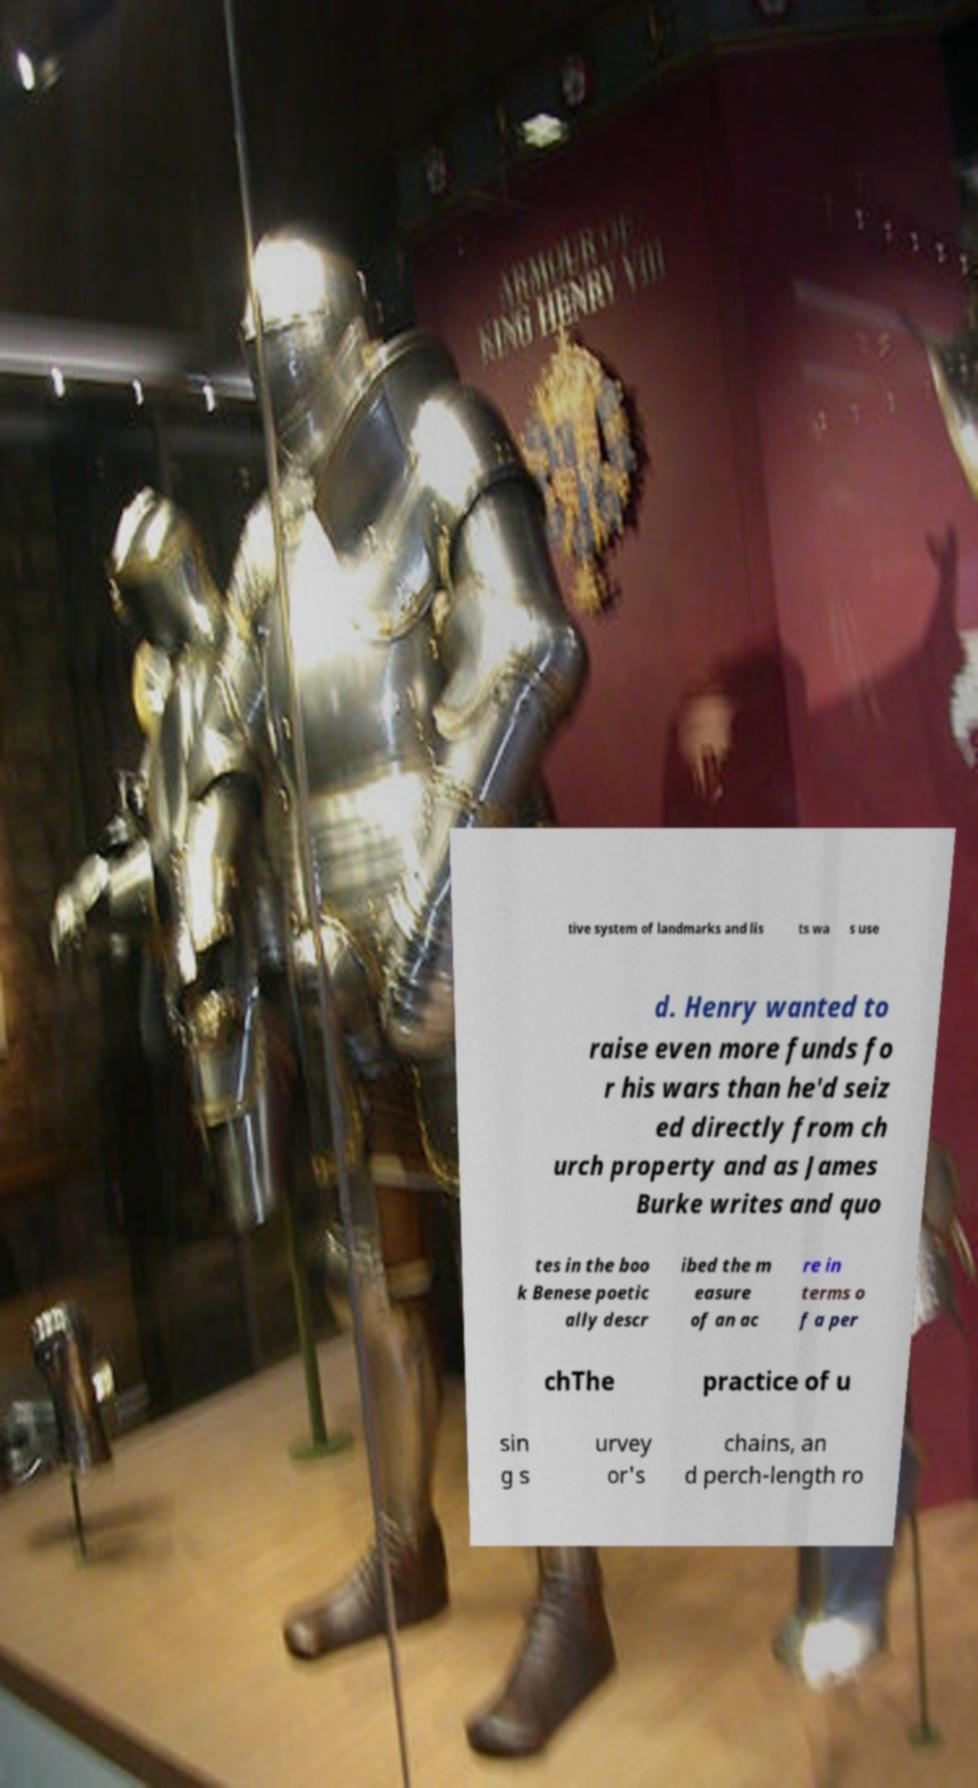Can you read and provide the text displayed in the image?This photo seems to have some interesting text. Can you extract and type it out for me? tive system of landmarks and lis ts wa s use d. Henry wanted to raise even more funds fo r his wars than he'd seiz ed directly from ch urch property and as James Burke writes and quo tes in the boo k Benese poetic ally descr ibed the m easure of an ac re in terms o f a per chThe practice of u sin g s urvey or's chains, an d perch-length ro 